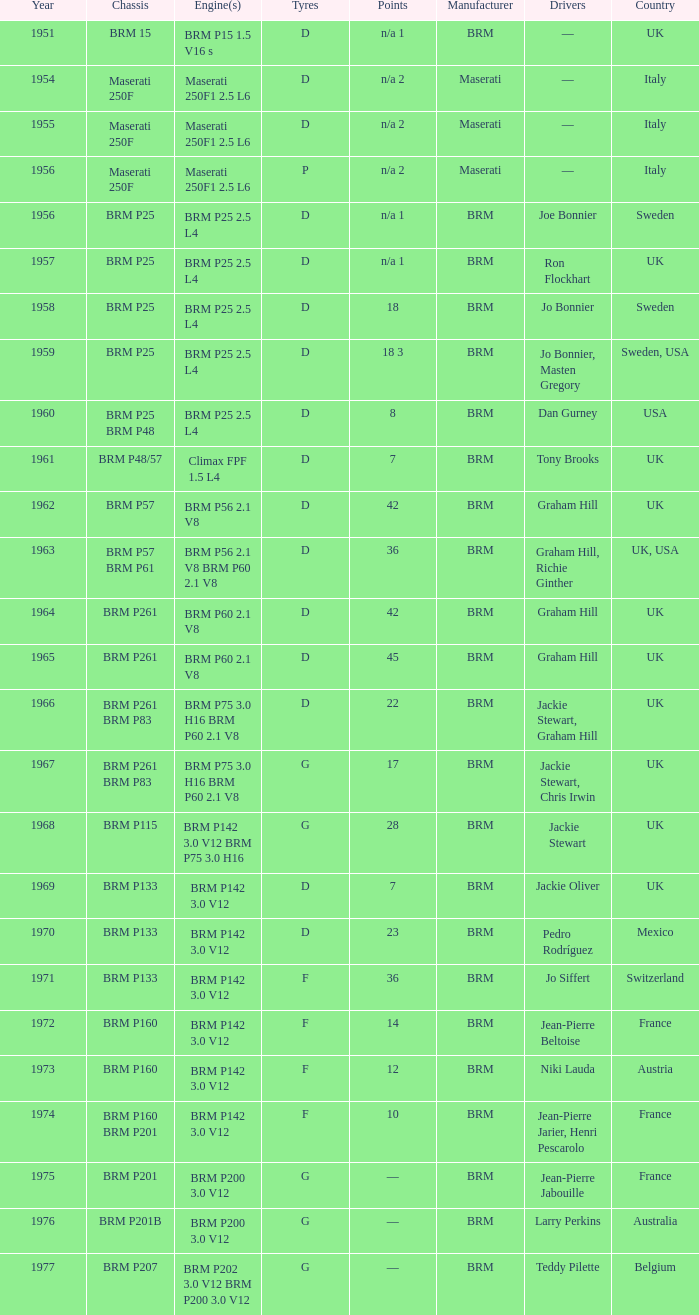Name the sum of year for engine of brm p202 3.0 v12 brm p200 3.0 v12 1977.0. 